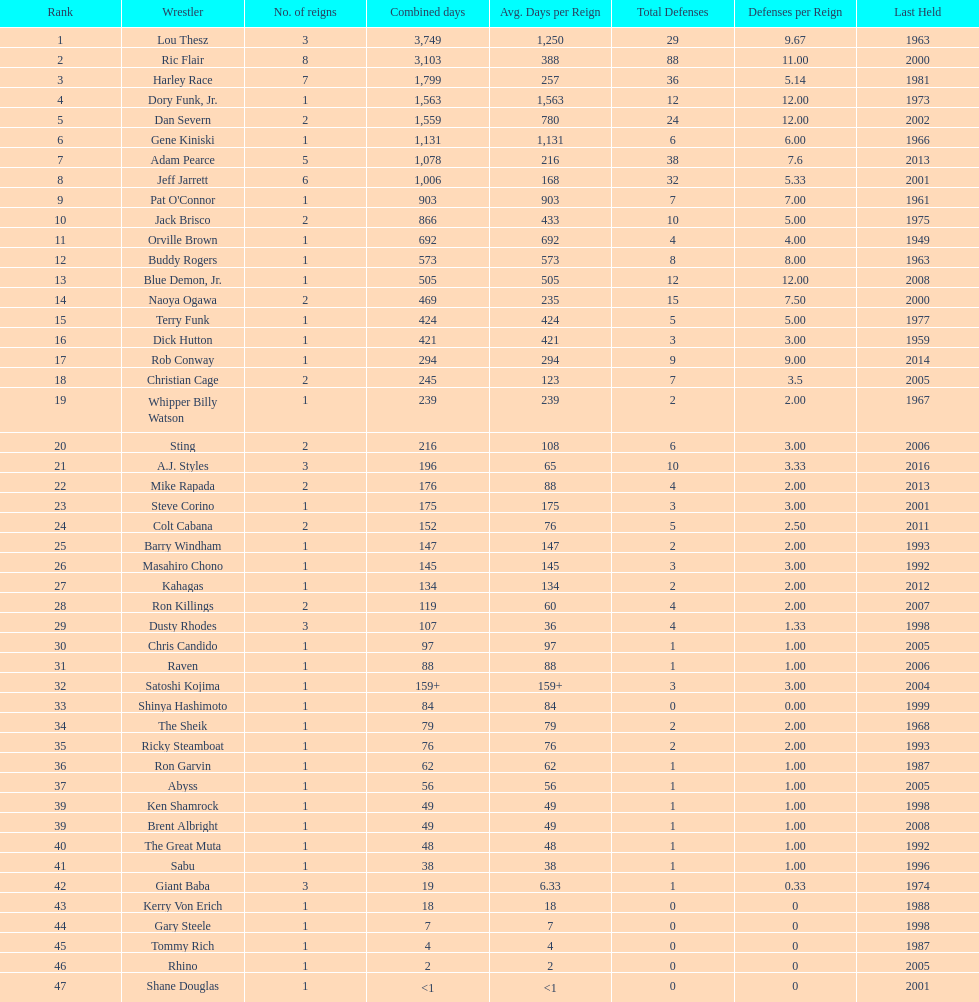Write the full table. {'header': ['Rank', 'Wrestler', 'No. of reigns', 'Combined days', 'Avg. Days per Reign', 'Total Defenses', 'Defenses per Reign', 'Last Held'], 'rows': [['1', 'Lou Thesz', '3', '3,749', '1,250', '29', '9.67', '1963'], ['2', 'Ric Flair', '8', '3,103', '388', '88', '11.00', '2000'], ['3', 'Harley Race', '7', '1,799', '257', '36', '5.14', '1981'], ['4', 'Dory Funk, Jr.', '1', '1,563', '1,563', '12', '12.00', '1973'], ['5', 'Dan Severn', '2', '1,559', '780', '24', '12.00', '2002'], ['6', 'Gene Kiniski', '1', '1,131', '1,131', '6', '6.00', '1966'], ['7', 'Adam Pearce', '5', '1,078', '216', '38', '7.6', '2013'], ['8', 'Jeff Jarrett', '6', '1,006', '168', '32', '5.33', '2001'], ['9', "Pat O'Connor", '1', '903', '903', '7', '7.00', '1961'], ['10', 'Jack Brisco', '2', '866', '433', '10', '5.00', '1975'], ['11', 'Orville Brown', '1', '692', '692', '4', '4.00', '1949'], ['12', 'Buddy Rogers', '1', '573', '573', '8', '8.00', '1963'], ['13', 'Blue Demon, Jr.', '1', '505', '505', '12', '12.00', '2008'], ['14', 'Naoya Ogawa', '2', '469', '235', '15', '7.50', '2000'], ['15', 'Terry Funk', '1', '424', '424', '5', '5.00', '1977'], ['16', 'Dick Hutton', '1', '421', '421', '3', '3.00', '1959'], ['17', 'Rob Conway', '1', '294', '294', '9', '9.00', '2014'], ['18', 'Christian Cage', '2', '245', '123', '7', '3.5', '2005'], ['19', 'Whipper Billy Watson', '1', '239', '239', '2', '2.00', '1967'], ['20', 'Sting', '2', '216', '108', '6', '3.00', '2006'], ['21', 'A.J. Styles', '3', '196', '65', '10', '3.33', '2016'], ['22', 'Mike Rapada', '2', '176', '88', '4', '2.00', '2013'], ['23', 'Steve Corino', '1', '175', '175', '3', '3.00', '2001'], ['24', 'Colt Cabana', '2', '152', '76', '5', '2.50', '2011'], ['25', 'Barry Windham', '1', '147', '147', '2', '2.00', '1993'], ['26', 'Masahiro Chono', '1', '145', '145', '3', '3.00', '1992'], ['27', 'Kahagas', '1', '134', '134', '2', '2.00', '2012'], ['28', 'Ron Killings', '2', '119', '60', '4', '2.00', '2007'], ['29', 'Dusty Rhodes', '3', '107', '36', '4', '1.33', '1998'], ['30', 'Chris Candido', '1', '97', '97', '1', '1.00', '2005'], ['31', 'Raven', '1', '88', '88', '1', '1.00', '2006'], ['32', 'Satoshi Kojima', '1', '159+', '159+', '3', '3.00', '2004'], ['33', 'Shinya Hashimoto', '1', '84', '84', '0', '0.00', '1999'], ['34', 'The Sheik', '1', '79', '79', '2', '2.00', '1968'], ['35', 'Ricky Steamboat', '1', '76', '76', '2', '2.00', '1993'], ['36', 'Ron Garvin', '1', '62', '62', '1', '1.00', '1987'], ['37', 'Abyss', '1', '56', '56', '1', '1.00', '2005'], ['39', 'Ken Shamrock', '1', '49', '49', '1', '1.00', '1998'], ['39', 'Brent Albright', '1', '49', '49', '1', '1.00', '2008'], ['40', 'The Great Muta', '1', '48', '48', '1', '1.00', '1992'], ['41', 'Sabu', '1', '38', '38', '1', '1.00', '1996'], ['42', 'Giant Baba', '3', '19', '6.33', '1', '0.33', '1974'], ['43', 'Kerry Von Erich', '1', '18', '18', '0', '0', '1988'], ['44', 'Gary Steele', '1', '7', '7', '0', '0', '1998'], ['45', 'Tommy Rich', '1', '4', '4', '0', '0', '1987'], ['46', 'Rhino', '1', '2', '2', '0', '0', '2005'], ['47', 'Shane Douglas', '1', '<1', '<1', '0', '0', '2001']]} How long did orville brown remain nwa world heavyweight champion? 692 days. 